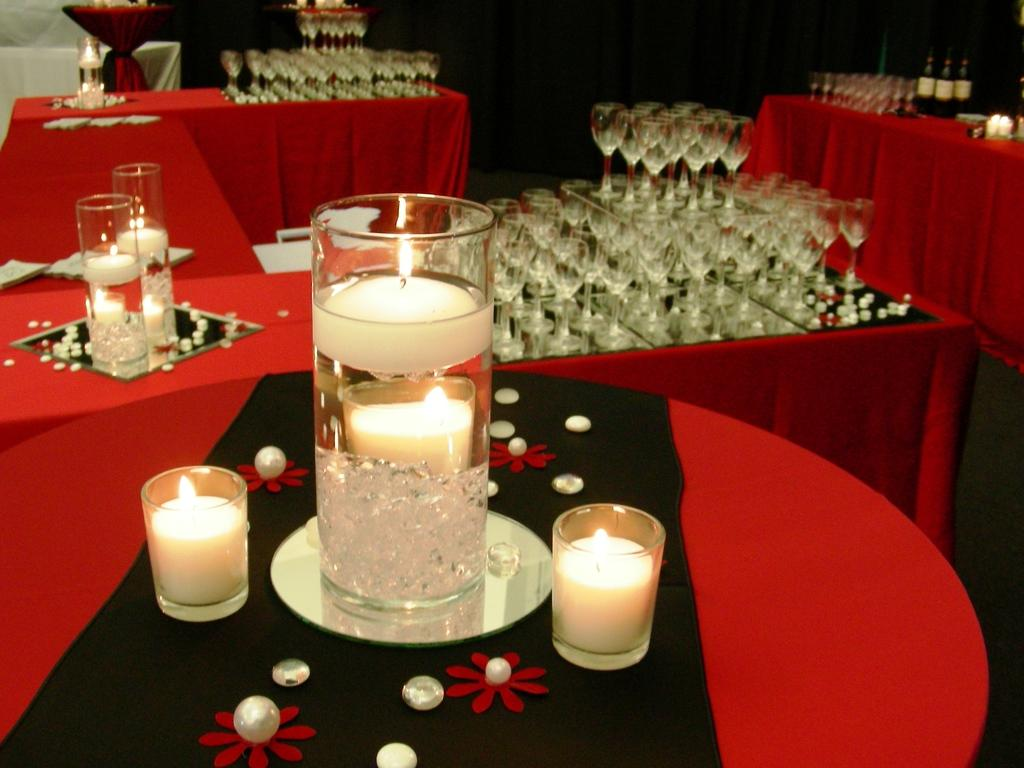What type of decorative items can be seen on the table in the image? There are decorative candles on the table. What type of glasses are on the table? There are wine glasses on the table. What else can be seen on the right side of the table? There are alcohol bottles on the right side of the table. Can you tell me how many farmers are present in the image? There are no farmers present in the image; it features decorative candles, wine glasses, and alcohol bottles on a table. What type of education can be seen taking place in the image? There is no education taking place in the image; it features decorative candles, wine glasses, and alcohol bottles on a table. 